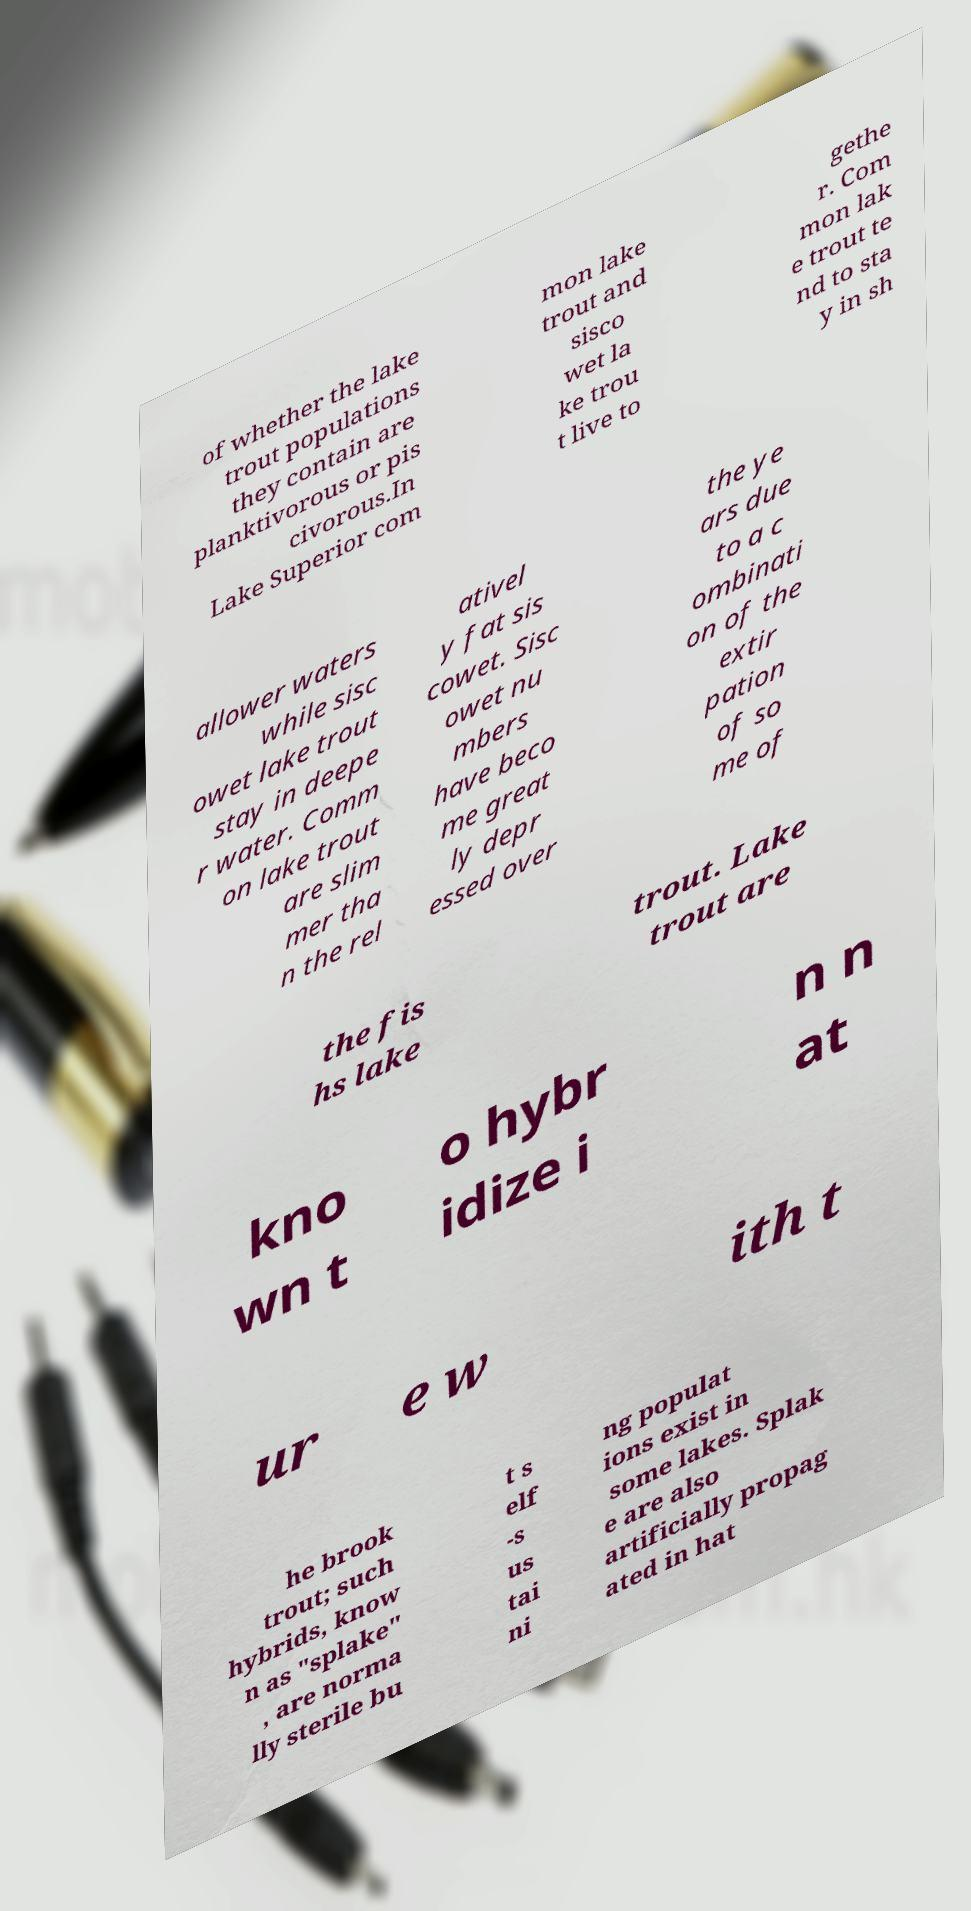What messages or text are displayed in this image? I need them in a readable, typed format. of whether the lake trout populations they contain are planktivorous or pis civorous.In Lake Superior com mon lake trout and sisco wet la ke trou t live to gethe r. Com mon lak e trout te nd to sta y in sh allower waters while sisc owet lake trout stay in deepe r water. Comm on lake trout are slim mer tha n the rel ativel y fat sis cowet. Sisc owet nu mbers have beco me great ly depr essed over the ye ars due to a c ombinati on of the extir pation of so me of the fis hs lake trout. Lake trout are kno wn t o hybr idize i n n at ur e w ith t he brook trout; such hybrids, know n as "splake" , are norma lly sterile bu t s elf -s us tai ni ng populat ions exist in some lakes. Splak e are also artificially propag ated in hat 